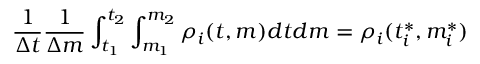Convert formula to latex. <formula><loc_0><loc_0><loc_500><loc_500>{ \frac { 1 } { \Delta t } } { \frac { 1 } { \Delta m } } \int _ { t _ { 1 } } ^ { t _ { 2 } } \int _ { m _ { 1 } } ^ { m _ { 2 } } \rho _ { i } ( t , m ) d t d m = \rho _ { i } ( t _ { i } ^ { * } , m _ { i } ^ { * } )</formula> 